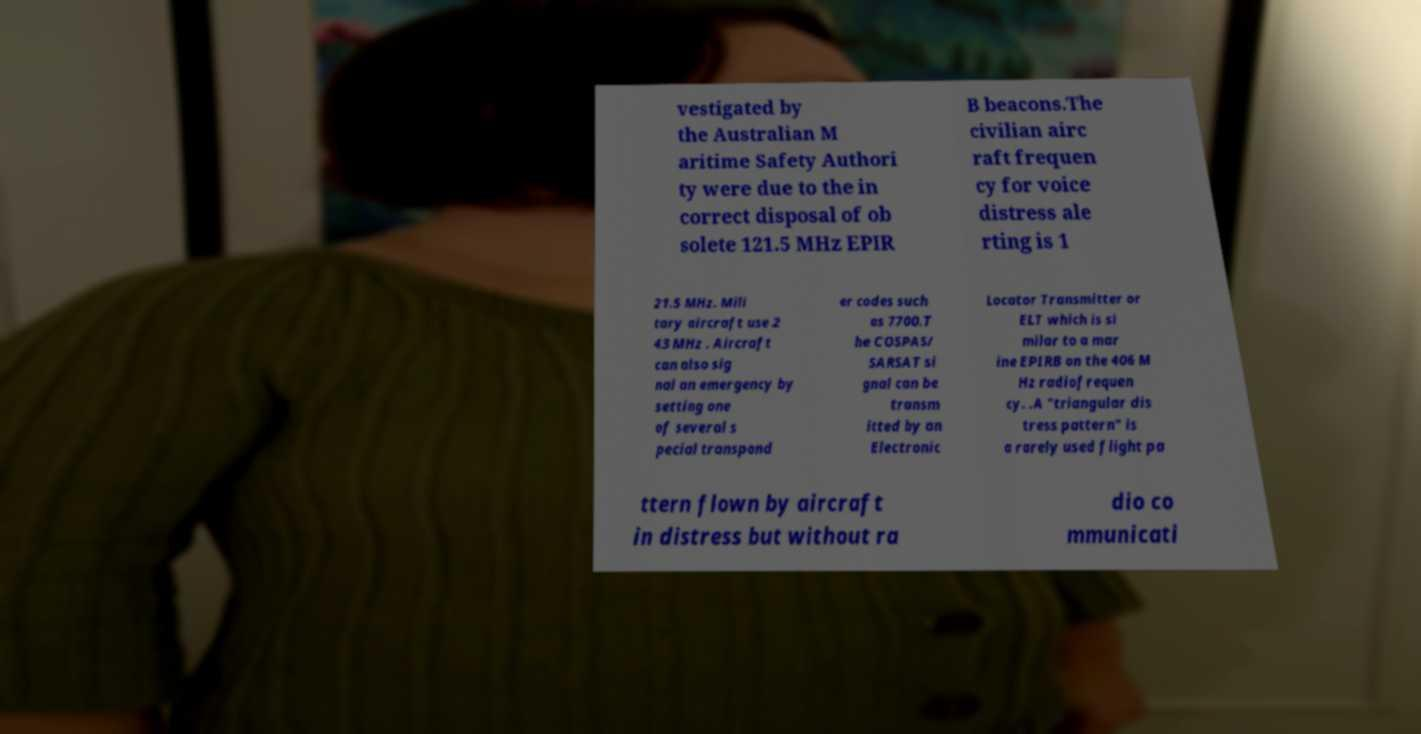There's text embedded in this image that I need extracted. Can you transcribe it verbatim? vestigated by the Australian M aritime Safety Authori ty were due to the in correct disposal of ob solete 121.5 MHz EPIR B beacons.The civilian airc raft frequen cy for voice distress ale rting is 1 21.5 MHz. Mili tary aircraft use 2 43 MHz . Aircraft can also sig nal an emergency by setting one of several s pecial transpond er codes such as 7700.T he COSPAS/ SARSAT si gnal can be transm itted by an Electronic Locator Transmitter or ELT which is si milar to a mar ine EPIRB on the 406 M Hz radiofrequen cy. .A "triangular dis tress pattern" is a rarely used flight pa ttern flown by aircraft in distress but without ra dio co mmunicati 